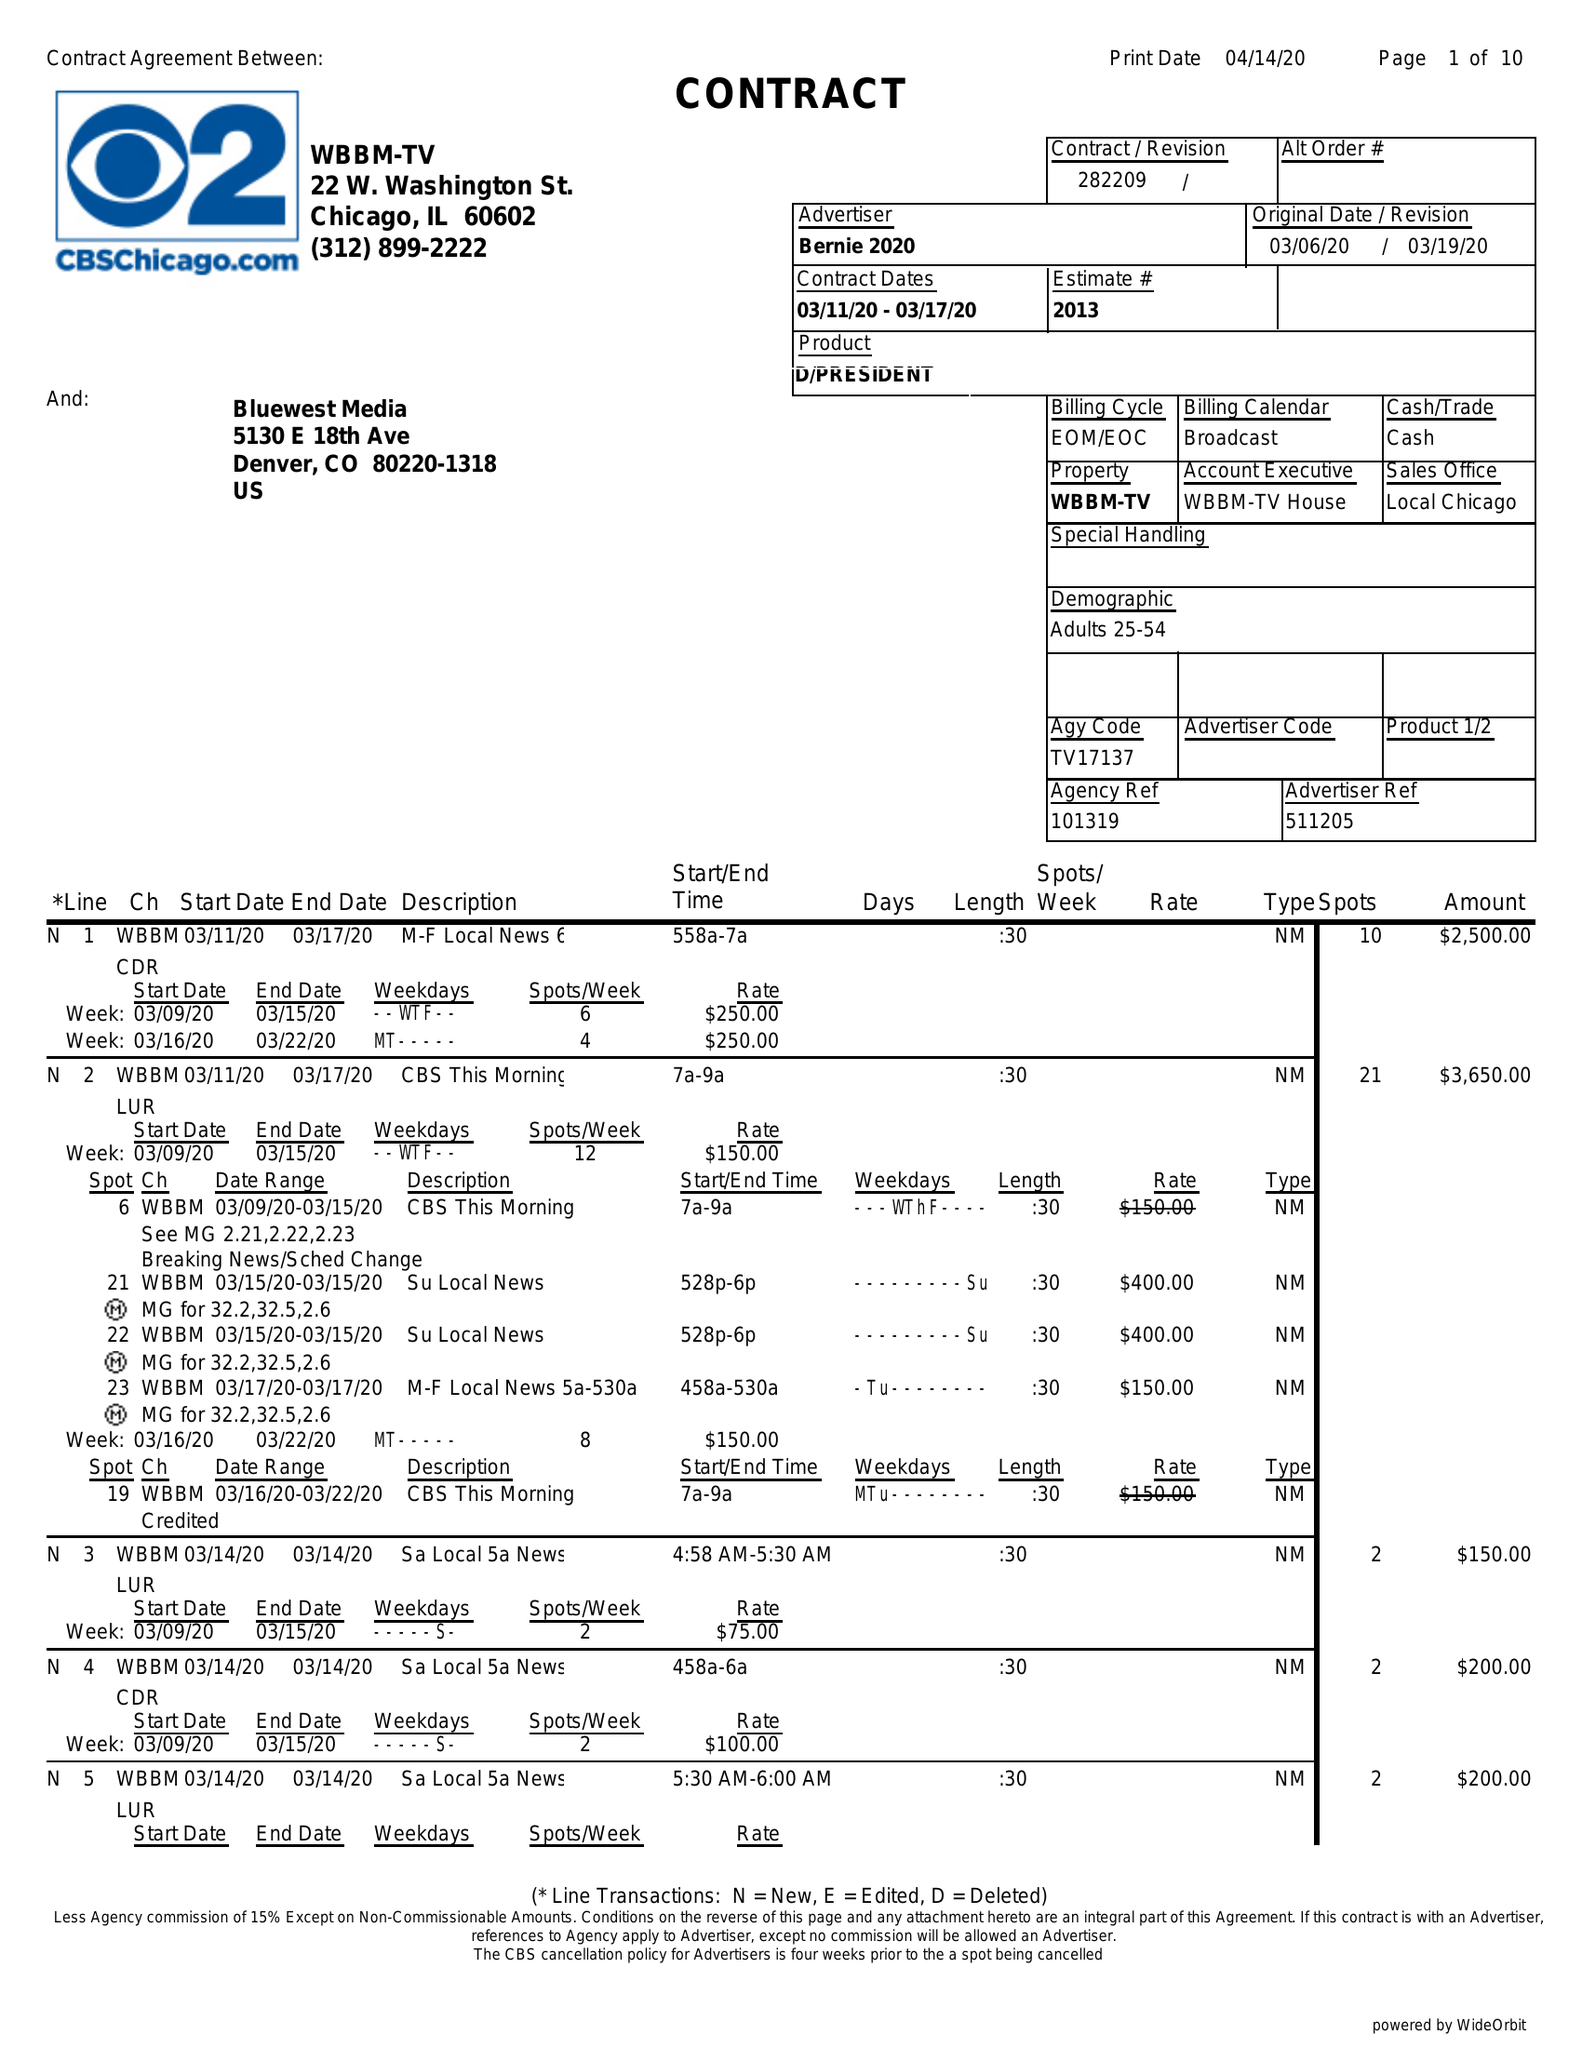What is the value for the flight_to?
Answer the question using a single word or phrase. 03/17/20 